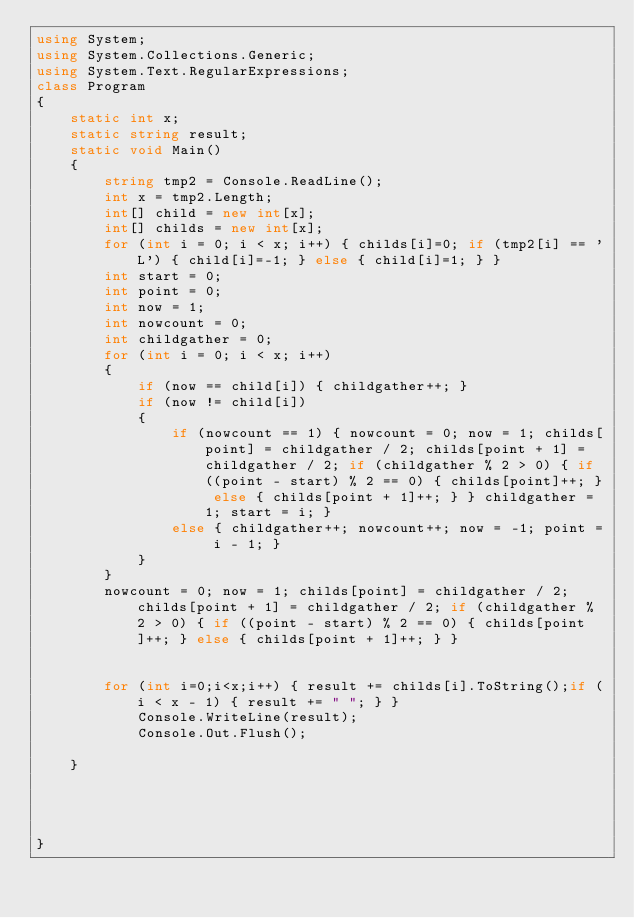<code> <loc_0><loc_0><loc_500><loc_500><_C#_>using System;
using System.Collections.Generic;
using System.Text.RegularExpressions;
class Program
{
    static int x;
    static string result;
    static void Main()
    {
        string tmp2 = Console.ReadLine();
        int x = tmp2.Length;
        int[] child = new int[x];
        int[] childs = new int[x];
        for (int i = 0; i < x; i++) { childs[i]=0; if (tmp2[i] == 'L') { child[i]=-1; } else { child[i]=1; } }
        int start = 0;
        int point = 0;
        int now = 1;
        int nowcount = 0;
        int childgather = 0;
        for (int i = 0; i < x; i++)
        {
            if (now == child[i]) { childgather++; }
            if (now != child[i])
            {
                if (nowcount == 1) { nowcount = 0; now = 1; childs[point] = childgather / 2; childs[point + 1] = childgather / 2; if (childgather % 2 > 0) { if ((point - start) % 2 == 0) { childs[point]++; } else { childs[point + 1]++; } } childgather = 1; start = i; }
                else { childgather++; nowcount++; now = -1; point = i - 1; }
            }
        }
        nowcount = 0; now = 1; childs[point] = childgather / 2; childs[point + 1] = childgather / 2; if (childgather % 2 > 0) { if ((point - start) % 2 == 0) { childs[point]++; } else { childs[point + 1]++; } }


        for (int i=0;i<x;i++) { result += childs[i].ToString();if (i < x - 1) { result += " "; } }
            Console.WriteLine(result);
            Console.Out.Flush();
        
    }

 


}</code> 